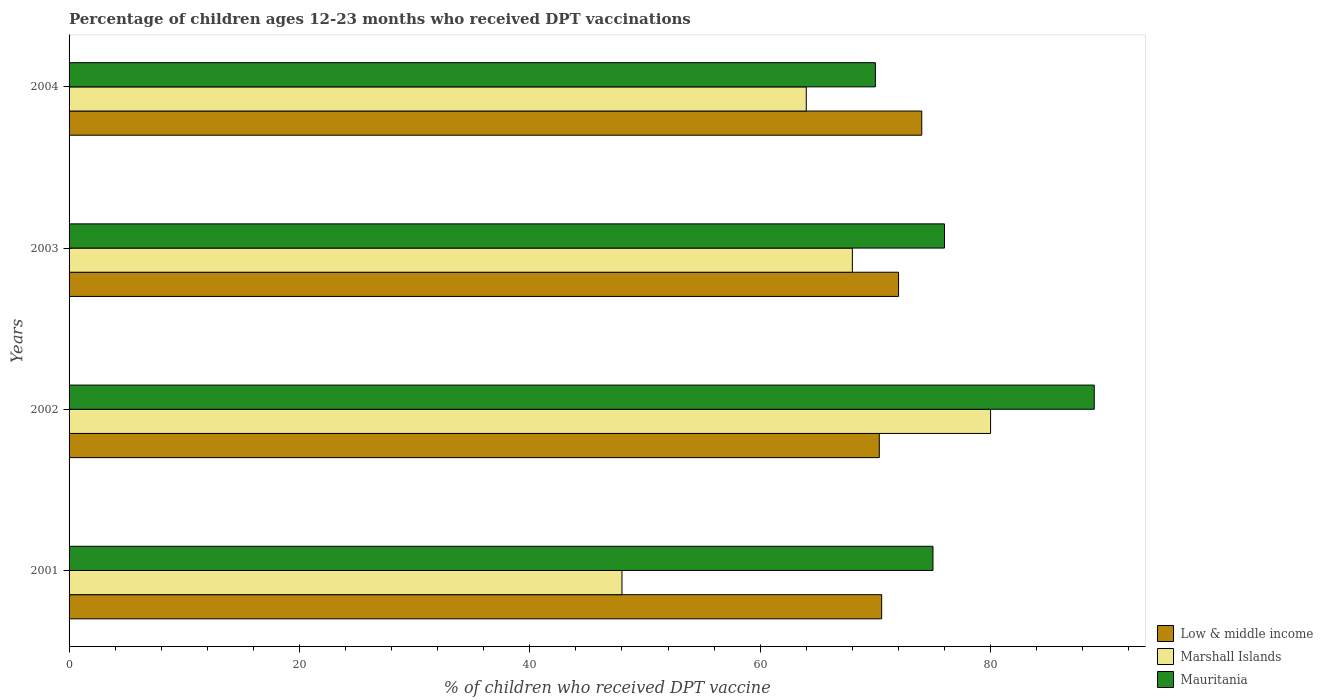How many groups of bars are there?
Keep it short and to the point. 4. Are the number of bars per tick equal to the number of legend labels?
Provide a succinct answer. Yes. Are the number of bars on each tick of the Y-axis equal?
Make the answer very short. Yes. How many bars are there on the 2nd tick from the top?
Your answer should be compact. 3. How many bars are there on the 4th tick from the bottom?
Give a very brief answer. 3. What is the label of the 4th group of bars from the top?
Offer a terse response. 2001. Across all years, what is the maximum percentage of children who received DPT vaccination in Marshall Islands?
Give a very brief answer. 80. Across all years, what is the minimum percentage of children who received DPT vaccination in Mauritania?
Your response must be concise. 70. In which year was the percentage of children who received DPT vaccination in Mauritania minimum?
Ensure brevity in your answer.  2004. What is the total percentage of children who received DPT vaccination in Marshall Islands in the graph?
Give a very brief answer. 260. What is the difference between the percentage of children who received DPT vaccination in Mauritania in 2001 and the percentage of children who received DPT vaccination in Marshall Islands in 2002?
Give a very brief answer. -5. What is the average percentage of children who received DPT vaccination in Mauritania per year?
Your answer should be compact. 77.5. In the year 2003, what is the difference between the percentage of children who received DPT vaccination in Low & middle income and percentage of children who received DPT vaccination in Marshall Islands?
Your response must be concise. 4.01. In how many years, is the percentage of children who received DPT vaccination in Mauritania greater than 72 %?
Give a very brief answer. 3. What is the ratio of the percentage of children who received DPT vaccination in Marshall Islands in 2001 to that in 2004?
Ensure brevity in your answer.  0.75. What is the difference between the highest and the lowest percentage of children who received DPT vaccination in Low & middle income?
Offer a very short reply. 3.69. In how many years, is the percentage of children who received DPT vaccination in Low & middle income greater than the average percentage of children who received DPT vaccination in Low & middle income taken over all years?
Provide a succinct answer. 2. Is the sum of the percentage of children who received DPT vaccination in Mauritania in 2001 and 2002 greater than the maximum percentage of children who received DPT vaccination in Marshall Islands across all years?
Provide a succinct answer. Yes. What does the 2nd bar from the top in 2001 represents?
Your answer should be compact. Marshall Islands. What does the 3rd bar from the bottom in 2003 represents?
Ensure brevity in your answer.  Mauritania. Is it the case that in every year, the sum of the percentage of children who received DPT vaccination in Mauritania and percentage of children who received DPT vaccination in Marshall Islands is greater than the percentage of children who received DPT vaccination in Low & middle income?
Make the answer very short. Yes. How many bars are there?
Make the answer very short. 12. Are all the bars in the graph horizontal?
Keep it short and to the point. Yes. Are the values on the major ticks of X-axis written in scientific E-notation?
Your response must be concise. No. Where does the legend appear in the graph?
Ensure brevity in your answer.  Bottom right. How many legend labels are there?
Your response must be concise. 3. What is the title of the graph?
Make the answer very short. Percentage of children ages 12-23 months who received DPT vaccinations. Does "Sub-Saharan Africa (developing only)" appear as one of the legend labels in the graph?
Offer a terse response. No. What is the label or title of the X-axis?
Offer a very short reply. % of children who received DPT vaccine. What is the % of children who received DPT vaccine in Low & middle income in 2001?
Give a very brief answer. 70.55. What is the % of children who received DPT vaccine of Marshall Islands in 2001?
Your response must be concise. 48. What is the % of children who received DPT vaccine in Low & middle income in 2002?
Provide a short and direct response. 70.34. What is the % of children who received DPT vaccine in Mauritania in 2002?
Give a very brief answer. 89. What is the % of children who received DPT vaccine in Low & middle income in 2003?
Offer a terse response. 72.01. What is the % of children who received DPT vaccine in Marshall Islands in 2003?
Your answer should be compact. 68. What is the % of children who received DPT vaccine of Mauritania in 2003?
Provide a short and direct response. 76. What is the % of children who received DPT vaccine of Low & middle income in 2004?
Provide a succinct answer. 74.03. Across all years, what is the maximum % of children who received DPT vaccine of Low & middle income?
Ensure brevity in your answer.  74.03. Across all years, what is the maximum % of children who received DPT vaccine of Mauritania?
Your answer should be compact. 89. Across all years, what is the minimum % of children who received DPT vaccine in Low & middle income?
Give a very brief answer. 70.34. What is the total % of children who received DPT vaccine of Low & middle income in the graph?
Keep it short and to the point. 286.92. What is the total % of children who received DPT vaccine in Marshall Islands in the graph?
Offer a terse response. 260. What is the total % of children who received DPT vaccine of Mauritania in the graph?
Your answer should be very brief. 310. What is the difference between the % of children who received DPT vaccine of Low & middle income in 2001 and that in 2002?
Keep it short and to the point. 0.21. What is the difference between the % of children who received DPT vaccine of Marshall Islands in 2001 and that in 2002?
Make the answer very short. -32. What is the difference between the % of children who received DPT vaccine in Mauritania in 2001 and that in 2002?
Make the answer very short. -14. What is the difference between the % of children who received DPT vaccine in Low & middle income in 2001 and that in 2003?
Provide a short and direct response. -1.47. What is the difference between the % of children who received DPT vaccine of Mauritania in 2001 and that in 2003?
Your answer should be compact. -1. What is the difference between the % of children who received DPT vaccine in Low & middle income in 2001 and that in 2004?
Offer a very short reply. -3.48. What is the difference between the % of children who received DPT vaccine of Marshall Islands in 2001 and that in 2004?
Give a very brief answer. -16. What is the difference between the % of children who received DPT vaccine in Low & middle income in 2002 and that in 2003?
Offer a terse response. -1.67. What is the difference between the % of children who received DPT vaccine in Marshall Islands in 2002 and that in 2003?
Make the answer very short. 12. What is the difference between the % of children who received DPT vaccine of Low & middle income in 2002 and that in 2004?
Make the answer very short. -3.69. What is the difference between the % of children who received DPT vaccine of Low & middle income in 2003 and that in 2004?
Ensure brevity in your answer.  -2.02. What is the difference between the % of children who received DPT vaccine in Marshall Islands in 2003 and that in 2004?
Make the answer very short. 4. What is the difference between the % of children who received DPT vaccine in Low & middle income in 2001 and the % of children who received DPT vaccine in Marshall Islands in 2002?
Provide a succinct answer. -9.45. What is the difference between the % of children who received DPT vaccine of Low & middle income in 2001 and the % of children who received DPT vaccine of Mauritania in 2002?
Give a very brief answer. -18.45. What is the difference between the % of children who received DPT vaccine in Marshall Islands in 2001 and the % of children who received DPT vaccine in Mauritania in 2002?
Ensure brevity in your answer.  -41. What is the difference between the % of children who received DPT vaccine in Low & middle income in 2001 and the % of children who received DPT vaccine in Marshall Islands in 2003?
Make the answer very short. 2.55. What is the difference between the % of children who received DPT vaccine of Low & middle income in 2001 and the % of children who received DPT vaccine of Mauritania in 2003?
Provide a short and direct response. -5.45. What is the difference between the % of children who received DPT vaccine of Low & middle income in 2001 and the % of children who received DPT vaccine of Marshall Islands in 2004?
Make the answer very short. 6.55. What is the difference between the % of children who received DPT vaccine in Low & middle income in 2001 and the % of children who received DPT vaccine in Mauritania in 2004?
Make the answer very short. 0.55. What is the difference between the % of children who received DPT vaccine in Low & middle income in 2002 and the % of children who received DPT vaccine in Marshall Islands in 2003?
Keep it short and to the point. 2.34. What is the difference between the % of children who received DPT vaccine of Low & middle income in 2002 and the % of children who received DPT vaccine of Mauritania in 2003?
Make the answer very short. -5.66. What is the difference between the % of children who received DPT vaccine of Marshall Islands in 2002 and the % of children who received DPT vaccine of Mauritania in 2003?
Offer a terse response. 4. What is the difference between the % of children who received DPT vaccine in Low & middle income in 2002 and the % of children who received DPT vaccine in Marshall Islands in 2004?
Make the answer very short. 6.34. What is the difference between the % of children who received DPT vaccine in Low & middle income in 2002 and the % of children who received DPT vaccine in Mauritania in 2004?
Make the answer very short. 0.34. What is the difference between the % of children who received DPT vaccine in Low & middle income in 2003 and the % of children who received DPT vaccine in Marshall Islands in 2004?
Ensure brevity in your answer.  8.01. What is the difference between the % of children who received DPT vaccine in Low & middle income in 2003 and the % of children who received DPT vaccine in Mauritania in 2004?
Your response must be concise. 2.01. What is the average % of children who received DPT vaccine in Low & middle income per year?
Provide a succinct answer. 71.73. What is the average % of children who received DPT vaccine of Marshall Islands per year?
Provide a short and direct response. 65. What is the average % of children who received DPT vaccine of Mauritania per year?
Your answer should be compact. 77.5. In the year 2001, what is the difference between the % of children who received DPT vaccine of Low & middle income and % of children who received DPT vaccine of Marshall Islands?
Keep it short and to the point. 22.55. In the year 2001, what is the difference between the % of children who received DPT vaccine in Low & middle income and % of children who received DPT vaccine in Mauritania?
Your response must be concise. -4.45. In the year 2001, what is the difference between the % of children who received DPT vaccine of Marshall Islands and % of children who received DPT vaccine of Mauritania?
Your answer should be very brief. -27. In the year 2002, what is the difference between the % of children who received DPT vaccine in Low & middle income and % of children who received DPT vaccine in Marshall Islands?
Your answer should be very brief. -9.66. In the year 2002, what is the difference between the % of children who received DPT vaccine in Low & middle income and % of children who received DPT vaccine in Mauritania?
Your answer should be compact. -18.66. In the year 2002, what is the difference between the % of children who received DPT vaccine of Marshall Islands and % of children who received DPT vaccine of Mauritania?
Your response must be concise. -9. In the year 2003, what is the difference between the % of children who received DPT vaccine of Low & middle income and % of children who received DPT vaccine of Marshall Islands?
Ensure brevity in your answer.  4.01. In the year 2003, what is the difference between the % of children who received DPT vaccine of Low & middle income and % of children who received DPT vaccine of Mauritania?
Offer a terse response. -3.99. In the year 2004, what is the difference between the % of children who received DPT vaccine in Low & middle income and % of children who received DPT vaccine in Marshall Islands?
Ensure brevity in your answer.  10.03. In the year 2004, what is the difference between the % of children who received DPT vaccine in Low & middle income and % of children who received DPT vaccine in Mauritania?
Give a very brief answer. 4.03. What is the ratio of the % of children who received DPT vaccine in Marshall Islands in 2001 to that in 2002?
Ensure brevity in your answer.  0.6. What is the ratio of the % of children who received DPT vaccine in Mauritania in 2001 to that in 2002?
Keep it short and to the point. 0.84. What is the ratio of the % of children who received DPT vaccine of Low & middle income in 2001 to that in 2003?
Your answer should be very brief. 0.98. What is the ratio of the % of children who received DPT vaccine in Marshall Islands in 2001 to that in 2003?
Provide a short and direct response. 0.71. What is the ratio of the % of children who received DPT vaccine in Mauritania in 2001 to that in 2003?
Provide a succinct answer. 0.99. What is the ratio of the % of children who received DPT vaccine of Low & middle income in 2001 to that in 2004?
Your response must be concise. 0.95. What is the ratio of the % of children who received DPT vaccine in Mauritania in 2001 to that in 2004?
Make the answer very short. 1.07. What is the ratio of the % of children who received DPT vaccine of Low & middle income in 2002 to that in 2003?
Make the answer very short. 0.98. What is the ratio of the % of children who received DPT vaccine of Marshall Islands in 2002 to that in 2003?
Keep it short and to the point. 1.18. What is the ratio of the % of children who received DPT vaccine in Mauritania in 2002 to that in 2003?
Your answer should be compact. 1.17. What is the ratio of the % of children who received DPT vaccine of Low & middle income in 2002 to that in 2004?
Ensure brevity in your answer.  0.95. What is the ratio of the % of children who received DPT vaccine of Marshall Islands in 2002 to that in 2004?
Your response must be concise. 1.25. What is the ratio of the % of children who received DPT vaccine in Mauritania in 2002 to that in 2004?
Provide a short and direct response. 1.27. What is the ratio of the % of children who received DPT vaccine of Low & middle income in 2003 to that in 2004?
Keep it short and to the point. 0.97. What is the ratio of the % of children who received DPT vaccine of Marshall Islands in 2003 to that in 2004?
Offer a terse response. 1.06. What is the ratio of the % of children who received DPT vaccine in Mauritania in 2003 to that in 2004?
Provide a succinct answer. 1.09. What is the difference between the highest and the second highest % of children who received DPT vaccine in Low & middle income?
Your answer should be very brief. 2.02. What is the difference between the highest and the second highest % of children who received DPT vaccine in Marshall Islands?
Provide a short and direct response. 12. What is the difference between the highest and the second highest % of children who received DPT vaccine in Mauritania?
Ensure brevity in your answer.  13. What is the difference between the highest and the lowest % of children who received DPT vaccine in Low & middle income?
Your response must be concise. 3.69. What is the difference between the highest and the lowest % of children who received DPT vaccine in Marshall Islands?
Offer a terse response. 32. 